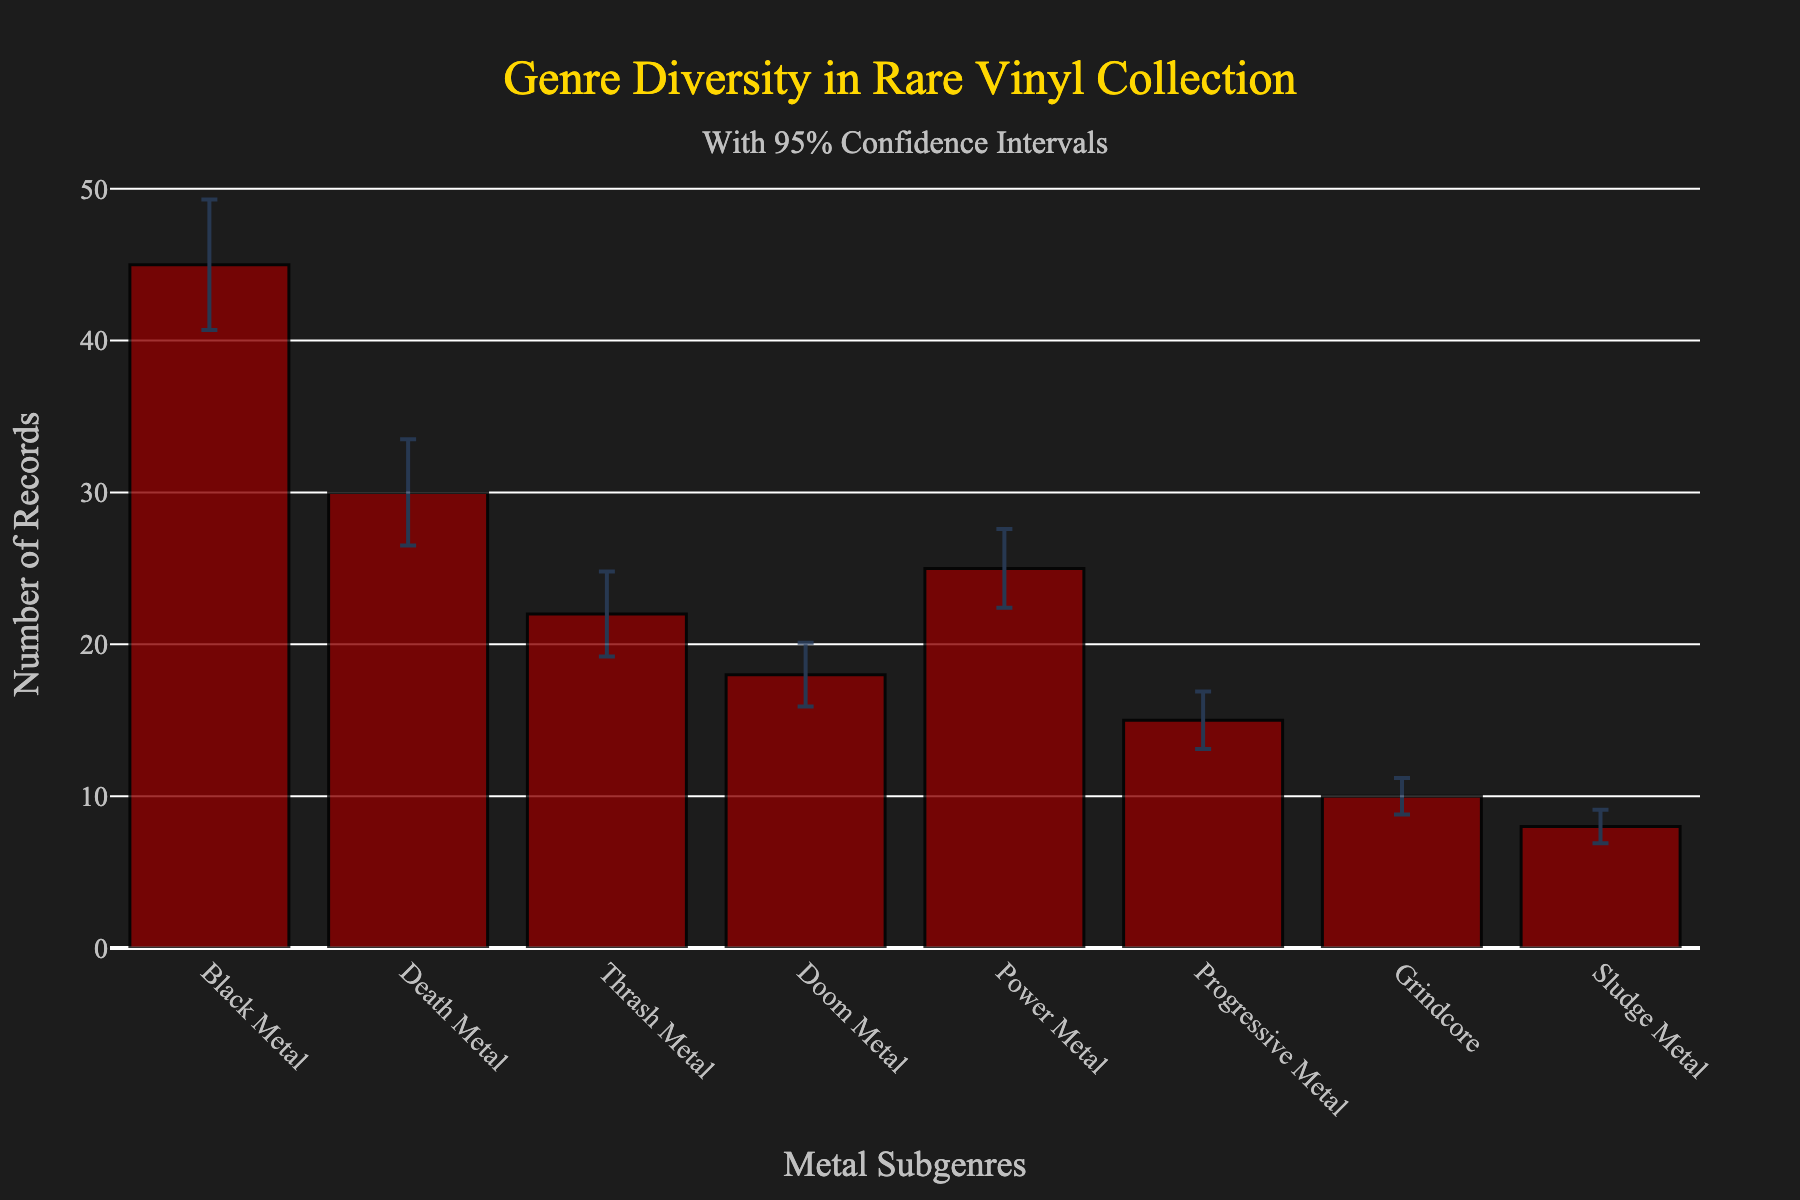what is the title of the chart? The title is located at the top of the chart and indicates the main subject of the chart. In this case, it describes the genre diversity in a rare vinyl records collection.
Answer: Genre Diversity in Rare Vinyl Collection What does the y-axis represent? The y-axis title is located on the left side of the chart. It indicates the measurement being displayed, which in this case, is the number of records for each genre.
Answer: Number of Records Which metal subgenre has the highest number of records? Look at the bars to see which one is the tallest. In this case, the Black Metal bar is the tallest, indicating the highest number.
Answer: Black Metal What is the approximate number of records for Grindcore? Refer to the bar corresponding to Grindcore. The height of the bar gives the mean count of records, approximately around 10.
Answer: 10 Which subgenre has the largest error bar? Error bars show the variability of the data. The subgenre with the largest error bar is Black Metal, as it has the longest vertical line extending from the top of the bar.
Answer: Black Metal How does the mean count of records for Doom Metal compare to Power Metal? Compare the height of the bars for Doom Metal and Power Metal. Doom Metal has about 18 records, whereas Power Metal has about 25 records. Power Metal has more records than Doom Metal.
Answer: Power Metal has more records than Doom Metal What is the mean count difference between Death Metal and Sludge Metal? Subtract the number of records for Sludge Metal from Death Metal. Death Metal has about 30 records, and Sludge Metal has about 8 records. Thus, the difference is 30 - 8.
Answer: 22 What is the sum of the mean counts for Black Metal, Death Metal, and Thrash Metal? Add the mean counts of the records for Black Metal (45), Death Metal (30), and Thrash Metal (22). So, 45 + 30 + 22 = 97.
Answer: 97 Which subgenre has the smallest number of records and what's its count? Look for the shortest bar. The shortest bar represents Sludge Metal, which has around 8 records.
Answer: Sludge Metal, 8 Is there any subgenre with a mean count between 20 and 30 records? If so, which one(s)? Check the genres with bar heights between the values of 20 and 30. Power Metal with 25 records falls in this range.
Answer: Power Metal 